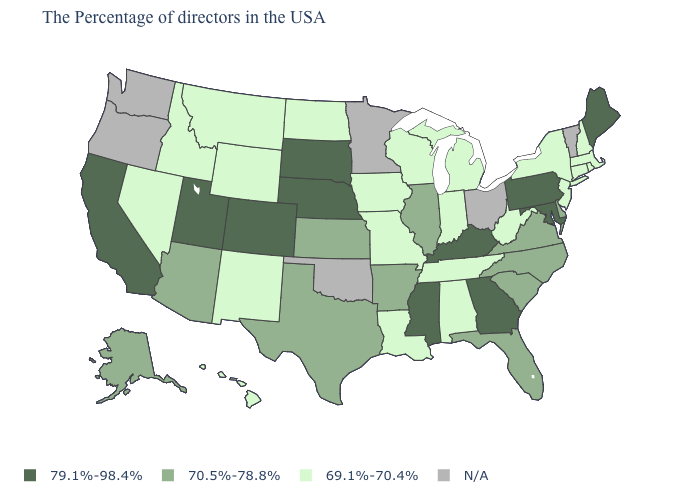Among the states that border Massachusetts , which have the lowest value?
Quick response, please. Rhode Island, New Hampshire, Connecticut, New York. Does Colorado have the highest value in the West?
Write a very short answer. Yes. Name the states that have a value in the range 70.5%-78.8%?
Be succinct. Delaware, Virginia, North Carolina, South Carolina, Florida, Illinois, Arkansas, Kansas, Texas, Arizona, Alaska. Among the states that border Illinois , which have the lowest value?
Give a very brief answer. Indiana, Wisconsin, Missouri, Iowa. What is the lowest value in states that border Colorado?
Keep it brief. 69.1%-70.4%. How many symbols are there in the legend?
Short answer required. 4. What is the value of Kentucky?
Answer briefly. 79.1%-98.4%. Which states have the lowest value in the USA?
Give a very brief answer. Massachusetts, Rhode Island, New Hampshire, Connecticut, New York, New Jersey, West Virginia, Michigan, Indiana, Alabama, Tennessee, Wisconsin, Louisiana, Missouri, Iowa, North Dakota, Wyoming, New Mexico, Montana, Idaho, Nevada, Hawaii. What is the highest value in states that border Oklahoma?
Give a very brief answer. 79.1%-98.4%. Does Alaska have the lowest value in the West?
Answer briefly. No. Which states have the highest value in the USA?
Keep it brief. Maine, Maryland, Pennsylvania, Georgia, Kentucky, Mississippi, Nebraska, South Dakota, Colorado, Utah, California. What is the highest value in the South ?
Concise answer only. 79.1%-98.4%. 